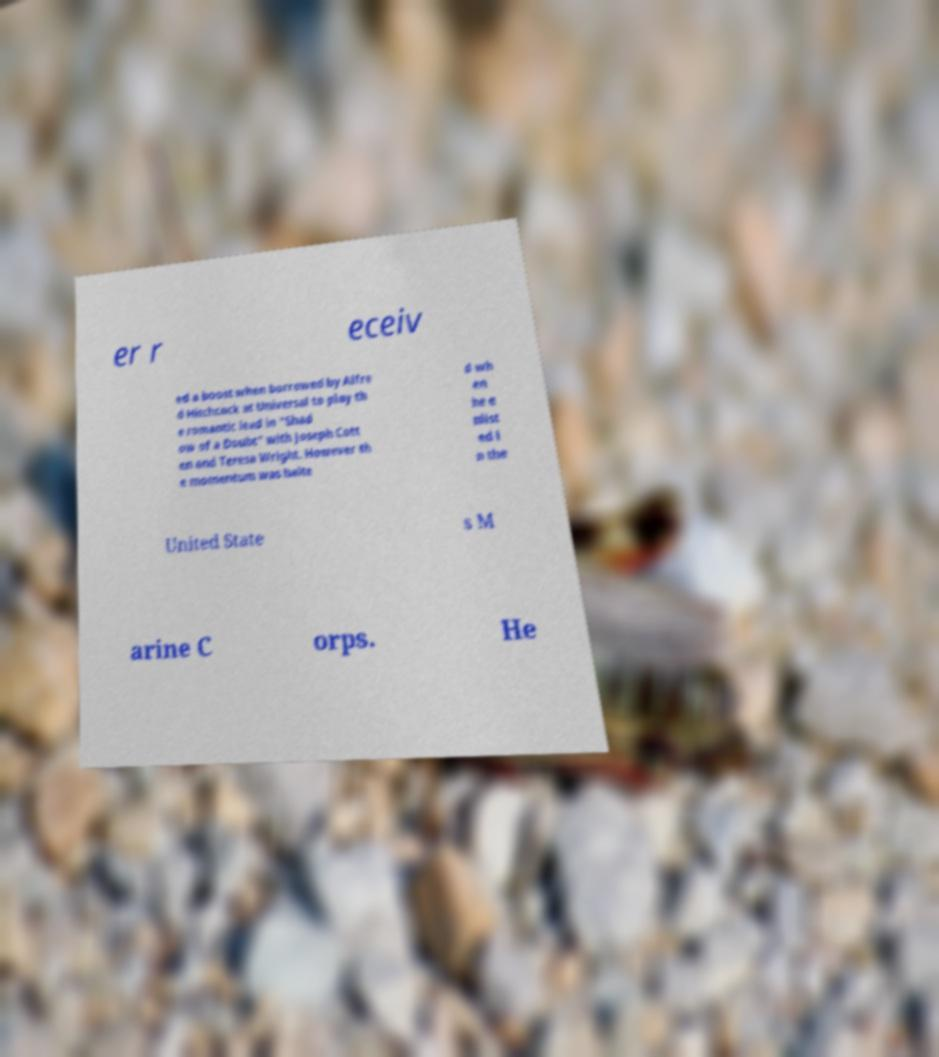Can you read and provide the text displayed in the image?This photo seems to have some interesting text. Can you extract and type it out for me? er r eceiv ed a boost when borrowed by Alfre d Hitchcock at Universal to play th e romantic lead in "Shad ow of a Doubt" with Joseph Cott en and Teresa Wright. However th e momentum was halte d wh en he e nlist ed i n the United State s M arine C orps. He 